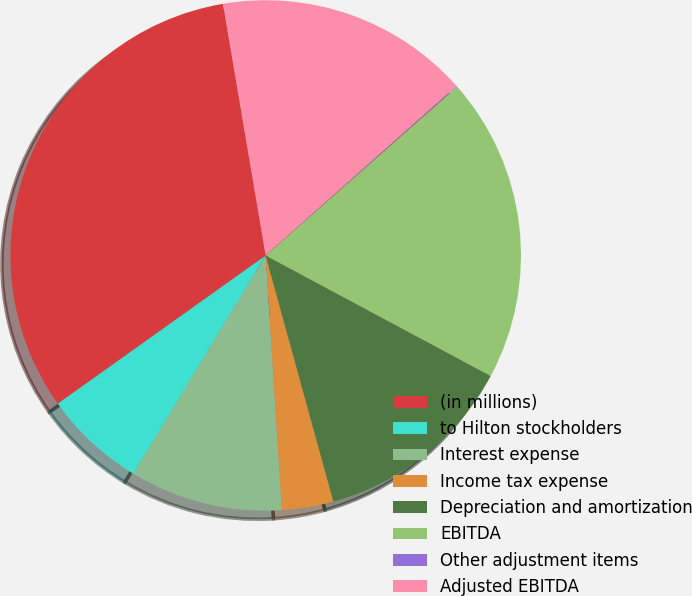<chart> <loc_0><loc_0><loc_500><loc_500><pie_chart><fcel>(in millions)<fcel>to Hilton stockholders<fcel>Interest expense<fcel>Income tax expense<fcel>Depreciation and amortization<fcel>EBITDA<fcel>Other adjustment items<fcel>Adjusted EBITDA<nl><fcel>32.18%<fcel>6.47%<fcel>9.69%<fcel>3.26%<fcel>12.9%<fcel>19.33%<fcel>0.05%<fcel>16.12%<nl></chart> 